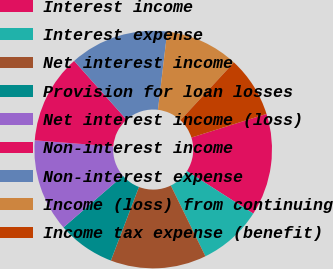Convert chart. <chart><loc_0><loc_0><loc_500><loc_500><pie_chart><fcel>Interest income<fcel>Interest expense<fcel>Net interest income<fcel>Provision for loan losses<fcel>Net interest income (loss)<fcel>Non-interest income<fcel>Non-interest expense<fcel>Income (loss) from continuing<fcel>Income tax expense (benefit)<nl><fcel>13.91%<fcel>8.7%<fcel>13.04%<fcel>7.83%<fcel>12.61%<fcel>12.17%<fcel>13.48%<fcel>10.0%<fcel>8.26%<nl></chart> 